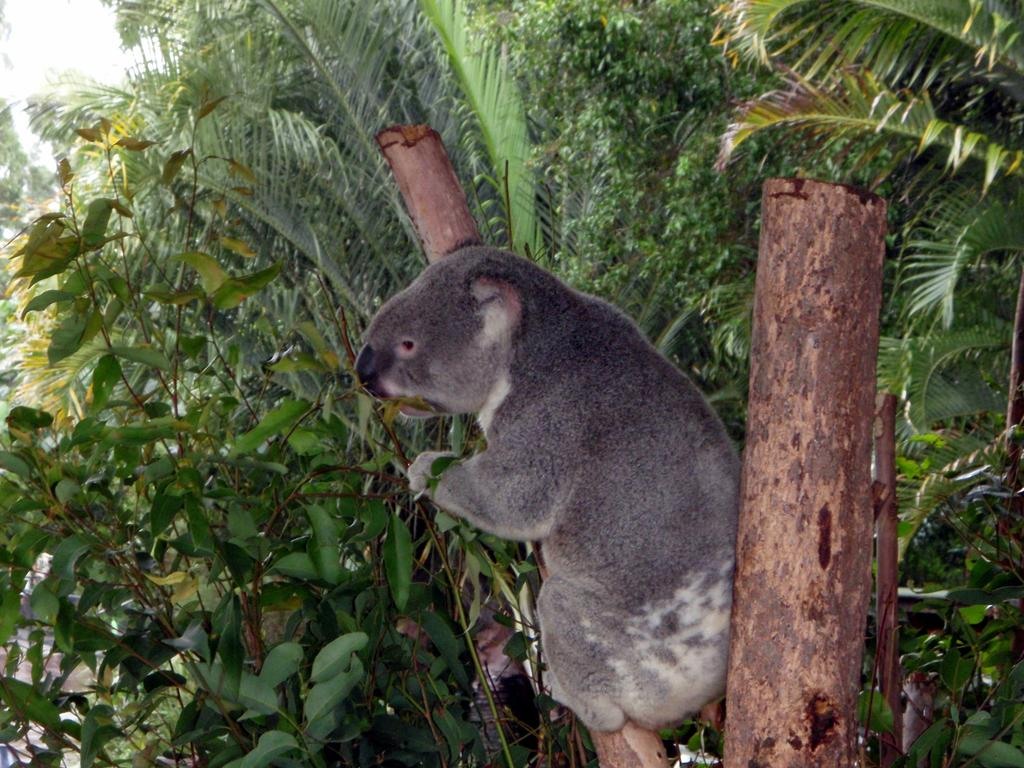What animal is featured in the image? There is a koala in the image. Where is the koala located? The koala is sitting on a branch of a tree. What can be seen in the background of the image? The sky is visible in the image. What type of pancake is the koala eating in the image? There is no pancake present in the image; the koala is sitting on a branch of a tree. How long does the koala's digestion process take in the image? The image does not provide information about the koala's digestion process, so it cannot be determined. 